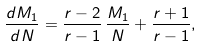Convert formula to latex. <formula><loc_0><loc_0><loc_500><loc_500>\frac { d M _ { 1 } } { d N } = \frac { r - 2 } { r - 1 } \, \frac { M _ { 1 } } { N } + \frac { r + 1 } { r - 1 } ,</formula> 